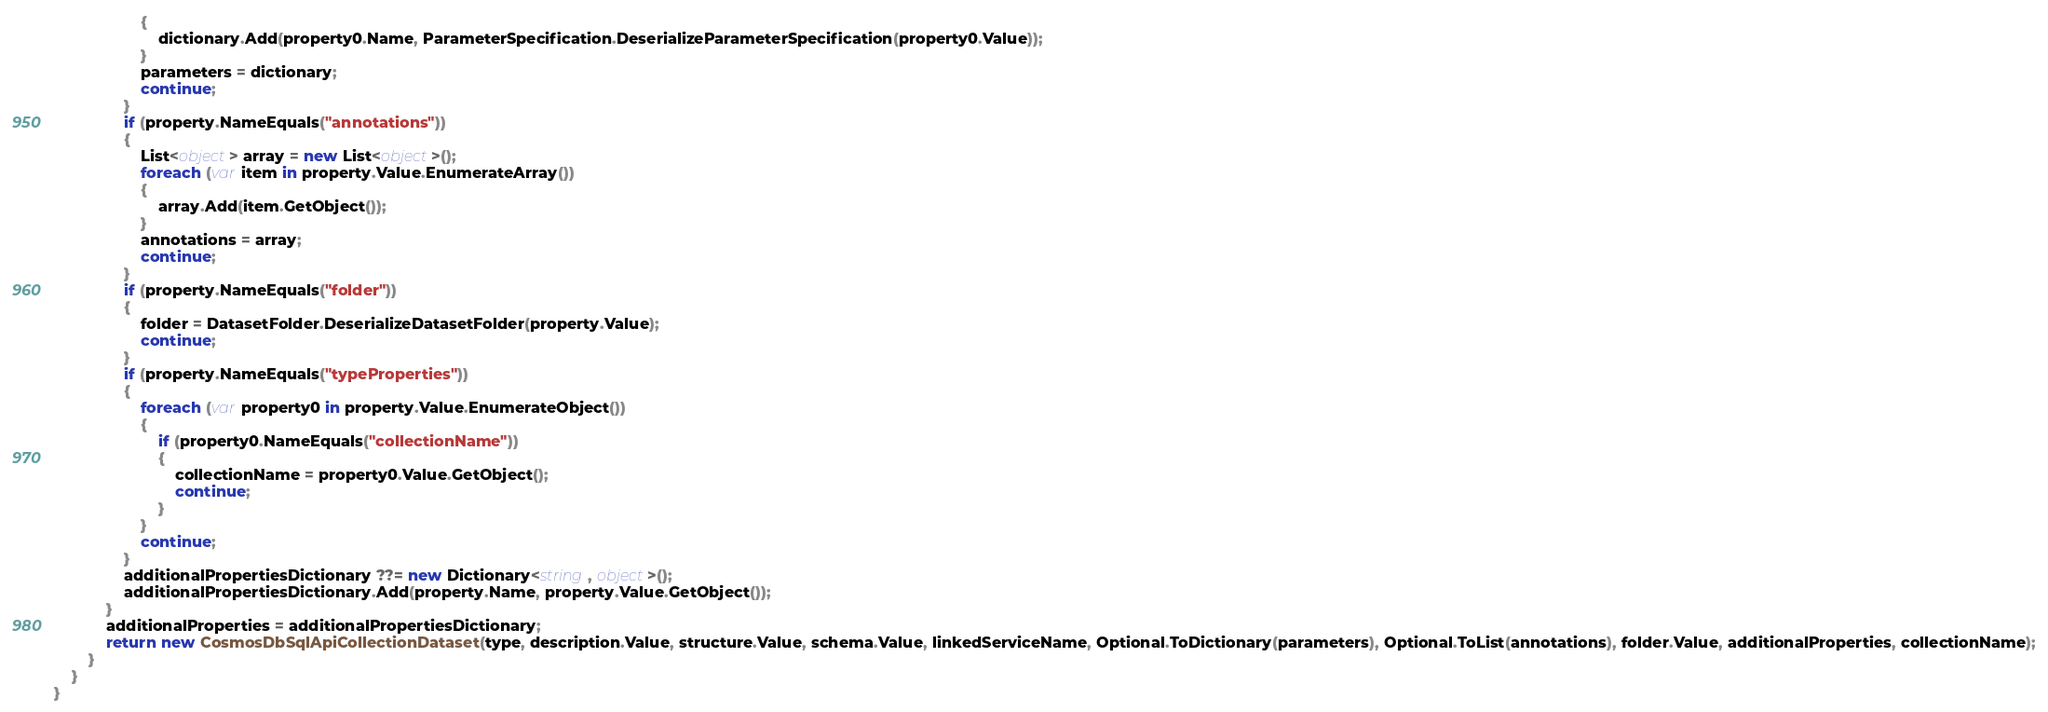Convert code to text. <code><loc_0><loc_0><loc_500><loc_500><_C#_>                    {
                        dictionary.Add(property0.Name, ParameterSpecification.DeserializeParameterSpecification(property0.Value));
                    }
                    parameters = dictionary;
                    continue;
                }
                if (property.NameEquals("annotations"))
                {
                    List<object> array = new List<object>();
                    foreach (var item in property.Value.EnumerateArray())
                    {
                        array.Add(item.GetObject());
                    }
                    annotations = array;
                    continue;
                }
                if (property.NameEquals("folder"))
                {
                    folder = DatasetFolder.DeserializeDatasetFolder(property.Value);
                    continue;
                }
                if (property.NameEquals("typeProperties"))
                {
                    foreach (var property0 in property.Value.EnumerateObject())
                    {
                        if (property0.NameEquals("collectionName"))
                        {
                            collectionName = property0.Value.GetObject();
                            continue;
                        }
                    }
                    continue;
                }
                additionalPropertiesDictionary ??= new Dictionary<string, object>();
                additionalPropertiesDictionary.Add(property.Name, property.Value.GetObject());
            }
            additionalProperties = additionalPropertiesDictionary;
            return new CosmosDbSqlApiCollectionDataset(type, description.Value, structure.Value, schema.Value, linkedServiceName, Optional.ToDictionary(parameters), Optional.ToList(annotations), folder.Value, additionalProperties, collectionName);
        }
    }
}
</code> 